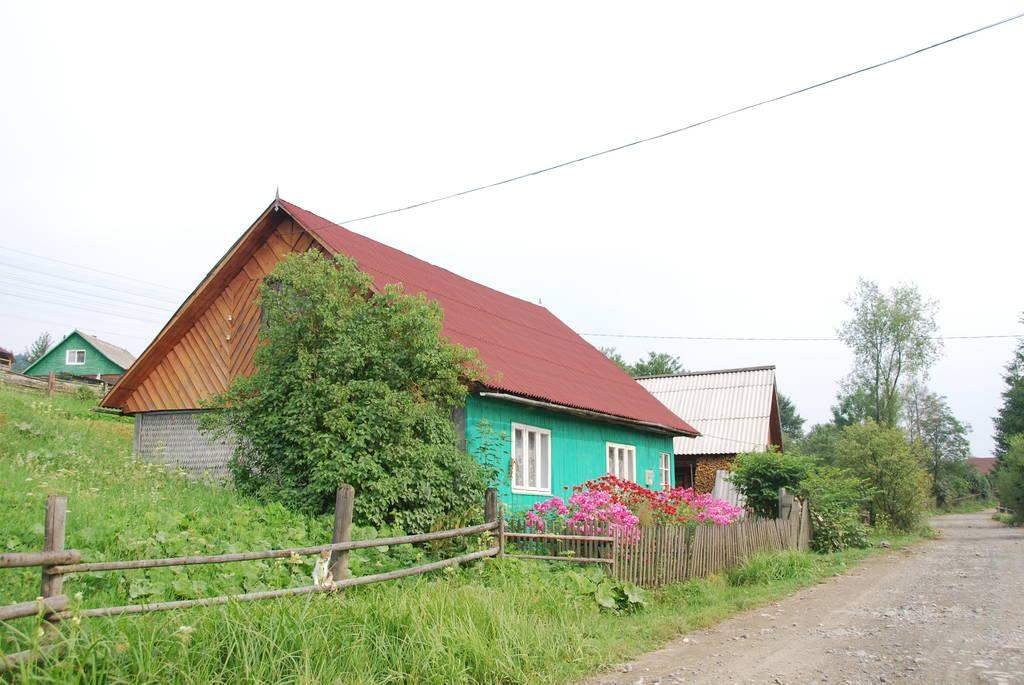What type of vegetation can be seen in the image? There is grass, plants, flowers, and trees in the image. What type of structures are present in the image? There are houses in the image. What type of barrier can be seen in the image? There is a wooden fence in the image. What is visible in the background of the image? The sky is visible in the background of the image. How many spots can be seen on the sun in the image? There is no sun visible in the image, and therefore no spots can be observed. 